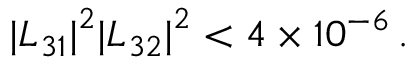Convert formula to latex. <formula><loc_0><loc_0><loc_500><loc_500>{ | L _ { 3 1 } | } ^ { 2 } { | L _ { 3 2 } | } ^ { 2 } < 4 \times 1 0 ^ { - 6 } \, .</formula> 